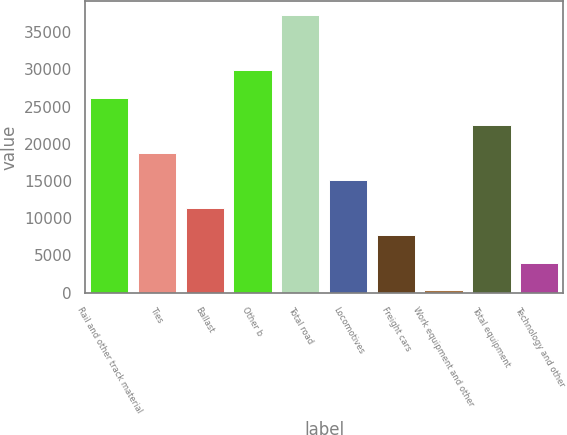<chart> <loc_0><loc_0><loc_500><loc_500><bar_chart><fcel>Rail and other track material<fcel>Ties<fcel>Ballast<fcel>Other b<fcel>Total road<fcel>Locomotives<fcel>Freight cars<fcel>Work equipment and other<fcel>Total equipment<fcel>Technology and other<nl><fcel>26179.1<fcel>18786.5<fcel>11393.9<fcel>29875.4<fcel>37268<fcel>15090.2<fcel>7697.6<fcel>305<fcel>22482.8<fcel>4001.3<nl></chart> 